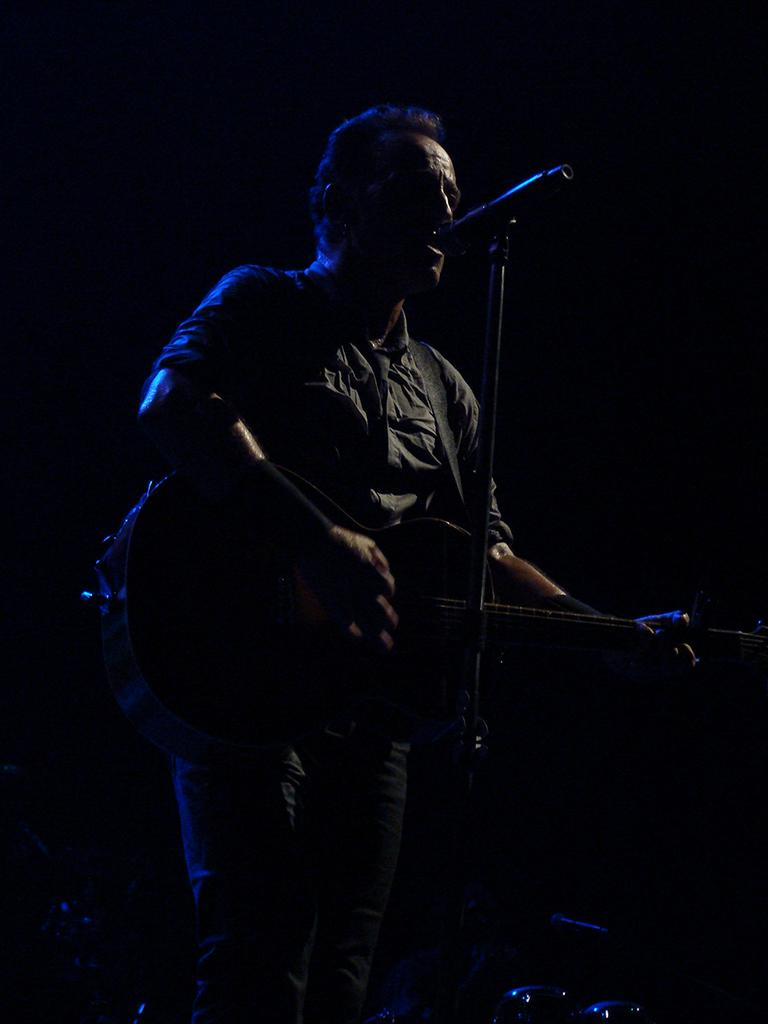What is the person in the image doing? The person is playing a guitar. What object is in front of the person? There is a microphone in front of the person. What type of cup is being used to play the guitar in the image? There is no cup present in the image, and the guitar is not being played with a cup. 